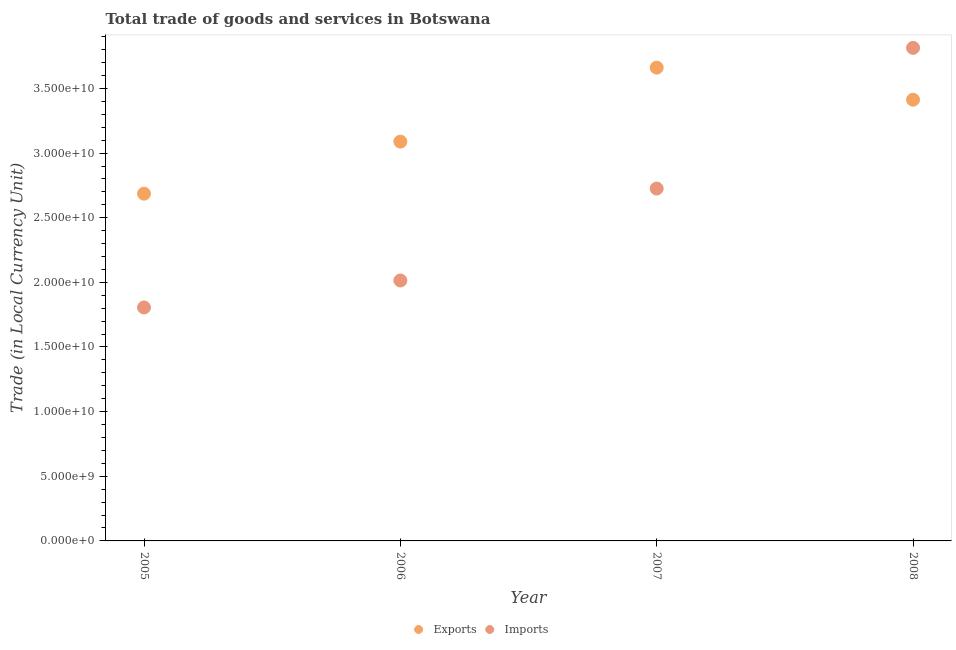How many different coloured dotlines are there?
Offer a terse response. 2. What is the imports of goods and services in 2006?
Offer a terse response. 2.01e+1. Across all years, what is the maximum imports of goods and services?
Your answer should be compact. 3.81e+1. Across all years, what is the minimum imports of goods and services?
Ensure brevity in your answer.  1.81e+1. In which year was the imports of goods and services minimum?
Your answer should be compact. 2005. What is the total imports of goods and services in the graph?
Provide a short and direct response. 1.04e+11. What is the difference between the imports of goods and services in 2006 and that in 2008?
Ensure brevity in your answer.  -1.80e+1. What is the difference between the export of goods and services in 2007 and the imports of goods and services in 2008?
Make the answer very short. -1.53e+09. What is the average imports of goods and services per year?
Your response must be concise. 2.59e+1. In the year 2008, what is the difference between the imports of goods and services and export of goods and services?
Your answer should be compact. 4.01e+09. In how many years, is the export of goods and services greater than 12000000000 LCU?
Give a very brief answer. 4. What is the ratio of the imports of goods and services in 2005 to that in 2008?
Keep it short and to the point. 0.47. Is the export of goods and services in 2007 less than that in 2008?
Give a very brief answer. No. What is the difference between the highest and the second highest imports of goods and services?
Offer a very short reply. 1.09e+1. What is the difference between the highest and the lowest export of goods and services?
Offer a terse response. 9.75e+09. In how many years, is the export of goods and services greater than the average export of goods and services taken over all years?
Provide a succinct answer. 2. Does the imports of goods and services monotonically increase over the years?
Offer a very short reply. Yes. Is the export of goods and services strictly greater than the imports of goods and services over the years?
Give a very brief answer. No. How many years are there in the graph?
Your response must be concise. 4. Are the values on the major ticks of Y-axis written in scientific E-notation?
Ensure brevity in your answer.  Yes. Does the graph contain any zero values?
Give a very brief answer. No. Does the graph contain grids?
Offer a terse response. No. How many legend labels are there?
Offer a terse response. 2. What is the title of the graph?
Keep it short and to the point. Total trade of goods and services in Botswana. What is the label or title of the Y-axis?
Give a very brief answer. Trade (in Local Currency Unit). What is the Trade (in Local Currency Unit) in Exports in 2005?
Give a very brief answer. 2.69e+1. What is the Trade (in Local Currency Unit) in Imports in 2005?
Your response must be concise. 1.81e+1. What is the Trade (in Local Currency Unit) in Exports in 2006?
Your response must be concise. 3.09e+1. What is the Trade (in Local Currency Unit) in Imports in 2006?
Your answer should be compact. 2.01e+1. What is the Trade (in Local Currency Unit) of Exports in 2007?
Give a very brief answer. 3.66e+1. What is the Trade (in Local Currency Unit) in Imports in 2007?
Your answer should be compact. 2.73e+1. What is the Trade (in Local Currency Unit) of Exports in 2008?
Offer a very short reply. 3.41e+1. What is the Trade (in Local Currency Unit) of Imports in 2008?
Your response must be concise. 3.81e+1. Across all years, what is the maximum Trade (in Local Currency Unit) of Exports?
Ensure brevity in your answer.  3.66e+1. Across all years, what is the maximum Trade (in Local Currency Unit) of Imports?
Provide a succinct answer. 3.81e+1. Across all years, what is the minimum Trade (in Local Currency Unit) in Exports?
Offer a very short reply. 2.69e+1. Across all years, what is the minimum Trade (in Local Currency Unit) of Imports?
Keep it short and to the point. 1.81e+1. What is the total Trade (in Local Currency Unit) of Exports in the graph?
Your answer should be very brief. 1.28e+11. What is the total Trade (in Local Currency Unit) in Imports in the graph?
Offer a very short reply. 1.04e+11. What is the difference between the Trade (in Local Currency Unit) in Exports in 2005 and that in 2006?
Offer a very short reply. -4.03e+09. What is the difference between the Trade (in Local Currency Unit) of Imports in 2005 and that in 2006?
Provide a short and direct response. -2.09e+09. What is the difference between the Trade (in Local Currency Unit) of Exports in 2005 and that in 2007?
Ensure brevity in your answer.  -9.75e+09. What is the difference between the Trade (in Local Currency Unit) of Imports in 2005 and that in 2007?
Your answer should be very brief. -9.20e+09. What is the difference between the Trade (in Local Currency Unit) of Exports in 2005 and that in 2008?
Provide a succinct answer. -7.27e+09. What is the difference between the Trade (in Local Currency Unit) of Imports in 2005 and that in 2008?
Give a very brief answer. -2.01e+1. What is the difference between the Trade (in Local Currency Unit) of Exports in 2006 and that in 2007?
Provide a succinct answer. -5.72e+09. What is the difference between the Trade (in Local Currency Unit) of Imports in 2006 and that in 2007?
Offer a terse response. -7.11e+09. What is the difference between the Trade (in Local Currency Unit) in Exports in 2006 and that in 2008?
Ensure brevity in your answer.  -3.24e+09. What is the difference between the Trade (in Local Currency Unit) of Imports in 2006 and that in 2008?
Make the answer very short. -1.80e+1. What is the difference between the Trade (in Local Currency Unit) of Exports in 2007 and that in 2008?
Your answer should be compact. 2.48e+09. What is the difference between the Trade (in Local Currency Unit) of Imports in 2007 and that in 2008?
Keep it short and to the point. -1.09e+1. What is the difference between the Trade (in Local Currency Unit) in Exports in 2005 and the Trade (in Local Currency Unit) in Imports in 2006?
Your answer should be compact. 6.72e+09. What is the difference between the Trade (in Local Currency Unit) of Exports in 2005 and the Trade (in Local Currency Unit) of Imports in 2007?
Give a very brief answer. -3.96e+08. What is the difference between the Trade (in Local Currency Unit) in Exports in 2005 and the Trade (in Local Currency Unit) in Imports in 2008?
Your response must be concise. -1.13e+1. What is the difference between the Trade (in Local Currency Unit) of Exports in 2006 and the Trade (in Local Currency Unit) of Imports in 2007?
Keep it short and to the point. 3.63e+09. What is the difference between the Trade (in Local Currency Unit) of Exports in 2006 and the Trade (in Local Currency Unit) of Imports in 2008?
Give a very brief answer. -7.25e+09. What is the difference between the Trade (in Local Currency Unit) of Exports in 2007 and the Trade (in Local Currency Unit) of Imports in 2008?
Your answer should be very brief. -1.53e+09. What is the average Trade (in Local Currency Unit) in Exports per year?
Offer a very short reply. 3.21e+1. What is the average Trade (in Local Currency Unit) of Imports per year?
Offer a very short reply. 2.59e+1. In the year 2005, what is the difference between the Trade (in Local Currency Unit) of Exports and Trade (in Local Currency Unit) of Imports?
Make the answer very short. 8.80e+09. In the year 2006, what is the difference between the Trade (in Local Currency Unit) of Exports and Trade (in Local Currency Unit) of Imports?
Offer a terse response. 1.07e+1. In the year 2007, what is the difference between the Trade (in Local Currency Unit) of Exports and Trade (in Local Currency Unit) of Imports?
Make the answer very short. 9.35e+09. In the year 2008, what is the difference between the Trade (in Local Currency Unit) in Exports and Trade (in Local Currency Unit) in Imports?
Keep it short and to the point. -4.01e+09. What is the ratio of the Trade (in Local Currency Unit) in Exports in 2005 to that in 2006?
Your response must be concise. 0.87. What is the ratio of the Trade (in Local Currency Unit) of Imports in 2005 to that in 2006?
Offer a terse response. 0.9. What is the ratio of the Trade (in Local Currency Unit) of Exports in 2005 to that in 2007?
Your response must be concise. 0.73. What is the ratio of the Trade (in Local Currency Unit) in Imports in 2005 to that in 2007?
Keep it short and to the point. 0.66. What is the ratio of the Trade (in Local Currency Unit) in Exports in 2005 to that in 2008?
Your response must be concise. 0.79. What is the ratio of the Trade (in Local Currency Unit) of Imports in 2005 to that in 2008?
Provide a succinct answer. 0.47. What is the ratio of the Trade (in Local Currency Unit) of Exports in 2006 to that in 2007?
Offer a very short reply. 0.84. What is the ratio of the Trade (in Local Currency Unit) of Imports in 2006 to that in 2007?
Your response must be concise. 0.74. What is the ratio of the Trade (in Local Currency Unit) of Exports in 2006 to that in 2008?
Offer a very short reply. 0.91. What is the ratio of the Trade (in Local Currency Unit) in Imports in 2006 to that in 2008?
Provide a short and direct response. 0.53. What is the ratio of the Trade (in Local Currency Unit) in Exports in 2007 to that in 2008?
Your answer should be compact. 1.07. What is the ratio of the Trade (in Local Currency Unit) in Imports in 2007 to that in 2008?
Offer a very short reply. 0.71. What is the difference between the highest and the second highest Trade (in Local Currency Unit) in Exports?
Offer a terse response. 2.48e+09. What is the difference between the highest and the second highest Trade (in Local Currency Unit) of Imports?
Your answer should be very brief. 1.09e+1. What is the difference between the highest and the lowest Trade (in Local Currency Unit) of Exports?
Provide a short and direct response. 9.75e+09. What is the difference between the highest and the lowest Trade (in Local Currency Unit) of Imports?
Your answer should be very brief. 2.01e+1. 